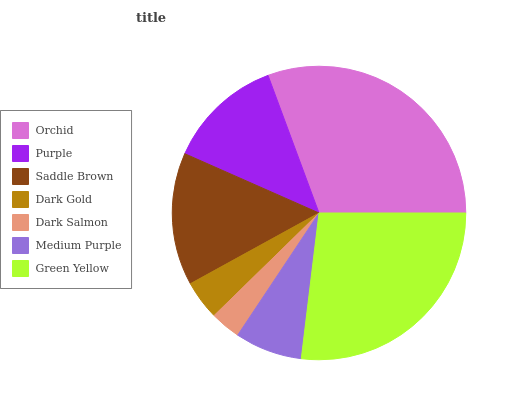Is Dark Salmon the minimum?
Answer yes or no. Yes. Is Orchid the maximum?
Answer yes or no. Yes. Is Purple the minimum?
Answer yes or no. No. Is Purple the maximum?
Answer yes or no. No. Is Orchid greater than Purple?
Answer yes or no. Yes. Is Purple less than Orchid?
Answer yes or no. Yes. Is Purple greater than Orchid?
Answer yes or no. No. Is Orchid less than Purple?
Answer yes or no. No. Is Purple the high median?
Answer yes or no. Yes. Is Purple the low median?
Answer yes or no. Yes. Is Orchid the high median?
Answer yes or no. No. Is Orchid the low median?
Answer yes or no. No. 